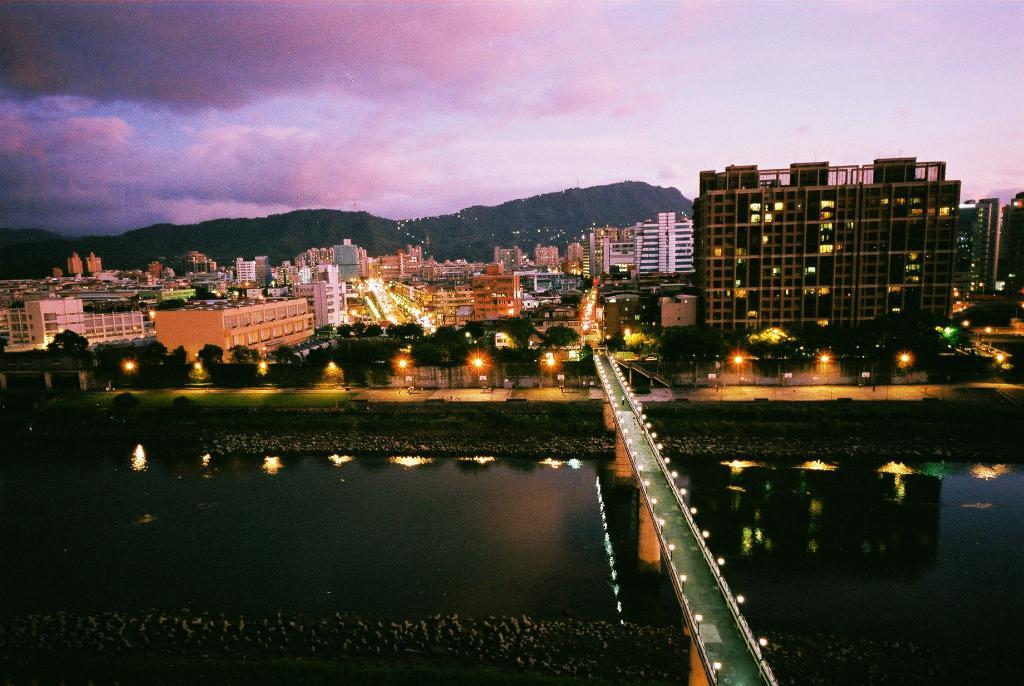What is the main structure in the image? There is a bridge in the image. What is the bridge positioned over? The bridge is over water. What can be seen in the background of the image? There are lights, trees, buildings, and hills visible in the background. What is the rate of the voyage depicted in the image? There is no voyage depicted in the image, as it simply shows a bridge over water with background elements. Can you see any flames in the image? There are no flames present in the image. 